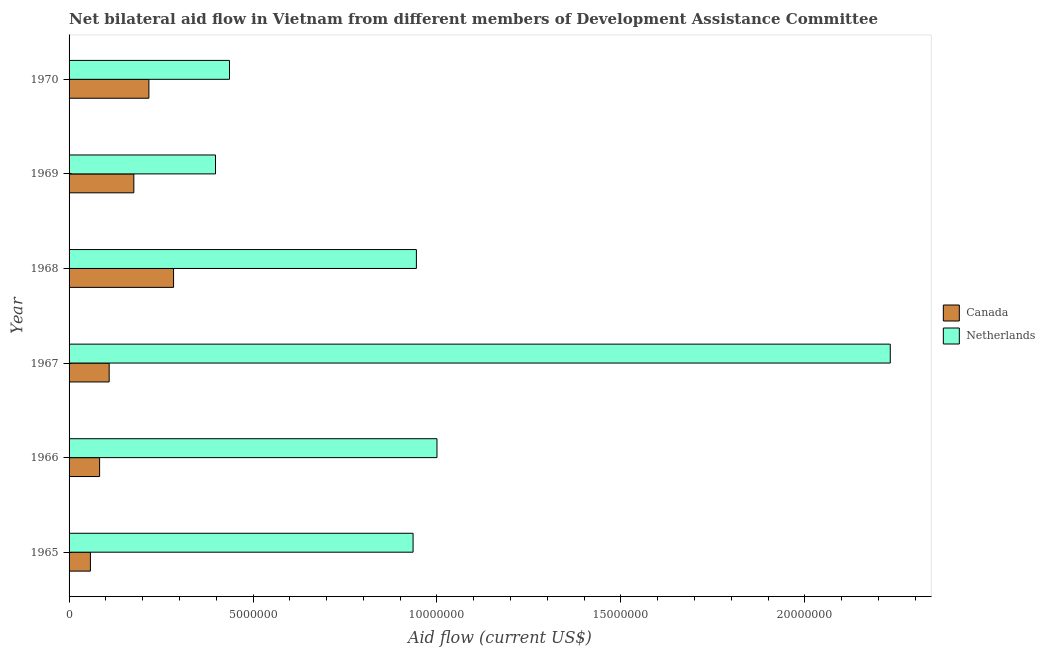Are the number of bars per tick equal to the number of legend labels?
Make the answer very short. Yes. Are the number of bars on each tick of the Y-axis equal?
Offer a terse response. Yes. What is the label of the 3rd group of bars from the top?
Provide a succinct answer. 1968. What is the amount of aid given by netherlands in 1965?
Your answer should be compact. 9.35e+06. Across all years, what is the maximum amount of aid given by canada?
Keep it short and to the point. 2.84e+06. Across all years, what is the minimum amount of aid given by netherlands?
Your answer should be very brief. 3.98e+06. In which year was the amount of aid given by netherlands maximum?
Provide a succinct answer. 1967. In which year was the amount of aid given by canada minimum?
Your answer should be compact. 1965. What is the total amount of aid given by netherlands in the graph?
Provide a succinct answer. 5.94e+07. What is the difference between the amount of aid given by netherlands in 1965 and that in 1967?
Provide a short and direct response. -1.30e+07. What is the difference between the amount of aid given by canada in 1966 and the amount of aid given by netherlands in 1970?
Make the answer very short. -3.53e+06. What is the average amount of aid given by canada per year?
Give a very brief answer. 1.54e+06. In the year 1969, what is the difference between the amount of aid given by canada and amount of aid given by netherlands?
Offer a very short reply. -2.22e+06. What is the ratio of the amount of aid given by canada in 1965 to that in 1969?
Your answer should be very brief. 0.33. Is the difference between the amount of aid given by netherlands in 1968 and 1969 greater than the difference between the amount of aid given by canada in 1968 and 1969?
Make the answer very short. Yes. What is the difference between the highest and the second highest amount of aid given by canada?
Your answer should be compact. 6.70e+05. What is the difference between the highest and the lowest amount of aid given by netherlands?
Offer a terse response. 1.83e+07. In how many years, is the amount of aid given by netherlands greater than the average amount of aid given by netherlands taken over all years?
Give a very brief answer. 2. What does the 2nd bar from the top in 1965 represents?
Keep it short and to the point. Canada. How many bars are there?
Your response must be concise. 12. How many years are there in the graph?
Keep it short and to the point. 6. Are the values on the major ticks of X-axis written in scientific E-notation?
Ensure brevity in your answer.  No. Does the graph contain any zero values?
Your answer should be compact. No. Does the graph contain grids?
Give a very brief answer. No. Where does the legend appear in the graph?
Your answer should be compact. Center right. How many legend labels are there?
Your answer should be compact. 2. What is the title of the graph?
Make the answer very short. Net bilateral aid flow in Vietnam from different members of Development Assistance Committee. Does "Lowest 20% of population" appear as one of the legend labels in the graph?
Offer a terse response. No. What is the Aid flow (current US$) of Canada in 1965?
Your answer should be compact. 5.80e+05. What is the Aid flow (current US$) of Netherlands in 1965?
Provide a short and direct response. 9.35e+06. What is the Aid flow (current US$) in Canada in 1966?
Your answer should be very brief. 8.30e+05. What is the Aid flow (current US$) of Netherlands in 1966?
Offer a very short reply. 1.00e+07. What is the Aid flow (current US$) of Canada in 1967?
Provide a short and direct response. 1.09e+06. What is the Aid flow (current US$) of Netherlands in 1967?
Make the answer very short. 2.23e+07. What is the Aid flow (current US$) of Canada in 1968?
Make the answer very short. 2.84e+06. What is the Aid flow (current US$) in Netherlands in 1968?
Ensure brevity in your answer.  9.44e+06. What is the Aid flow (current US$) in Canada in 1969?
Give a very brief answer. 1.76e+06. What is the Aid flow (current US$) of Netherlands in 1969?
Provide a succinct answer. 3.98e+06. What is the Aid flow (current US$) of Canada in 1970?
Make the answer very short. 2.17e+06. What is the Aid flow (current US$) in Netherlands in 1970?
Keep it short and to the point. 4.36e+06. Across all years, what is the maximum Aid flow (current US$) in Canada?
Provide a short and direct response. 2.84e+06. Across all years, what is the maximum Aid flow (current US$) of Netherlands?
Ensure brevity in your answer.  2.23e+07. Across all years, what is the minimum Aid flow (current US$) of Canada?
Your answer should be very brief. 5.80e+05. Across all years, what is the minimum Aid flow (current US$) in Netherlands?
Provide a succinct answer. 3.98e+06. What is the total Aid flow (current US$) of Canada in the graph?
Your answer should be very brief. 9.27e+06. What is the total Aid flow (current US$) in Netherlands in the graph?
Give a very brief answer. 5.94e+07. What is the difference between the Aid flow (current US$) of Canada in 1965 and that in 1966?
Ensure brevity in your answer.  -2.50e+05. What is the difference between the Aid flow (current US$) in Netherlands in 1965 and that in 1966?
Offer a terse response. -6.50e+05. What is the difference between the Aid flow (current US$) of Canada in 1965 and that in 1967?
Offer a terse response. -5.10e+05. What is the difference between the Aid flow (current US$) of Netherlands in 1965 and that in 1967?
Ensure brevity in your answer.  -1.30e+07. What is the difference between the Aid flow (current US$) of Canada in 1965 and that in 1968?
Ensure brevity in your answer.  -2.26e+06. What is the difference between the Aid flow (current US$) in Netherlands in 1965 and that in 1968?
Give a very brief answer. -9.00e+04. What is the difference between the Aid flow (current US$) of Canada in 1965 and that in 1969?
Your answer should be compact. -1.18e+06. What is the difference between the Aid flow (current US$) in Netherlands in 1965 and that in 1969?
Make the answer very short. 5.37e+06. What is the difference between the Aid flow (current US$) in Canada in 1965 and that in 1970?
Offer a very short reply. -1.59e+06. What is the difference between the Aid flow (current US$) in Netherlands in 1965 and that in 1970?
Offer a terse response. 4.99e+06. What is the difference between the Aid flow (current US$) of Canada in 1966 and that in 1967?
Give a very brief answer. -2.60e+05. What is the difference between the Aid flow (current US$) of Netherlands in 1966 and that in 1967?
Provide a succinct answer. -1.23e+07. What is the difference between the Aid flow (current US$) in Canada in 1966 and that in 1968?
Provide a short and direct response. -2.01e+06. What is the difference between the Aid flow (current US$) of Netherlands in 1966 and that in 1968?
Give a very brief answer. 5.60e+05. What is the difference between the Aid flow (current US$) in Canada in 1966 and that in 1969?
Offer a very short reply. -9.30e+05. What is the difference between the Aid flow (current US$) of Netherlands in 1966 and that in 1969?
Your answer should be compact. 6.02e+06. What is the difference between the Aid flow (current US$) in Canada in 1966 and that in 1970?
Offer a terse response. -1.34e+06. What is the difference between the Aid flow (current US$) in Netherlands in 1966 and that in 1970?
Ensure brevity in your answer.  5.64e+06. What is the difference between the Aid flow (current US$) in Canada in 1967 and that in 1968?
Give a very brief answer. -1.75e+06. What is the difference between the Aid flow (current US$) of Netherlands in 1967 and that in 1968?
Offer a very short reply. 1.29e+07. What is the difference between the Aid flow (current US$) of Canada in 1967 and that in 1969?
Ensure brevity in your answer.  -6.70e+05. What is the difference between the Aid flow (current US$) of Netherlands in 1967 and that in 1969?
Offer a very short reply. 1.83e+07. What is the difference between the Aid flow (current US$) in Canada in 1967 and that in 1970?
Keep it short and to the point. -1.08e+06. What is the difference between the Aid flow (current US$) of Netherlands in 1967 and that in 1970?
Ensure brevity in your answer.  1.80e+07. What is the difference between the Aid flow (current US$) in Canada in 1968 and that in 1969?
Your answer should be compact. 1.08e+06. What is the difference between the Aid flow (current US$) in Netherlands in 1968 and that in 1969?
Your answer should be compact. 5.46e+06. What is the difference between the Aid flow (current US$) in Canada in 1968 and that in 1970?
Provide a succinct answer. 6.70e+05. What is the difference between the Aid flow (current US$) in Netherlands in 1968 and that in 1970?
Provide a short and direct response. 5.08e+06. What is the difference between the Aid flow (current US$) in Canada in 1969 and that in 1970?
Keep it short and to the point. -4.10e+05. What is the difference between the Aid flow (current US$) in Netherlands in 1969 and that in 1970?
Your answer should be very brief. -3.80e+05. What is the difference between the Aid flow (current US$) in Canada in 1965 and the Aid flow (current US$) in Netherlands in 1966?
Offer a very short reply. -9.42e+06. What is the difference between the Aid flow (current US$) in Canada in 1965 and the Aid flow (current US$) in Netherlands in 1967?
Ensure brevity in your answer.  -2.17e+07. What is the difference between the Aid flow (current US$) in Canada in 1965 and the Aid flow (current US$) in Netherlands in 1968?
Ensure brevity in your answer.  -8.86e+06. What is the difference between the Aid flow (current US$) in Canada in 1965 and the Aid flow (current US$) in Netherlands in 1969?
Make the answer very short. -3.40e+06. What is the difference between the Aid flow (current US$) in Canada in 1965 and the Aid flow (current US$) in Netherlands in 1970?
Offer a terse response. -3.78e+06. What is the difference between the Aid flow (current US$) of Canada in 1966 and the Aid flow (current US$) of Netherlands in 1967?
Offer a terse response. -2.15e+07. What is the difference between the Aid flow (current US$) of Canada in 1966 and the Aid flow (current US$) of Netherlands in 1968?
Provide a succinct answer. -8.61e+06. What is the difference between the Aid flow (current US$) in Canada in 1966 and the Aid flow (current US$) in Netherlands in 1969?
Keep it short and to the point. -3.15e+06. What is the difference between the Aid flow (current US$) of Canada in 1966 and the Aid flow (current US$) of Netherlands in 1970?
Your response must be concise. -3.53e+06. What is the difference between the Aid flow (current US$) in Canada in 1967 and the Aid flow (current US$) in Netherlands in 1968?
Your response must be concise. -8.35e+06. What is the difference between the Aid flow (current US$) of Canada in 1967 and the Aid flow (current US$) of Netherlands in 1969?
Provide a short and direct response. -2.89e+06. What is the difference between the Aid flow (current US$) in Canada in 1967 and the Aid flow (current US$) in Netherlands in 1970?
Your answer should be very brief. -3.27e+06. What is the difference between the Aid flow (current US$) of Canada in 1968 and the Aid flow (current US$) of Netherlands in 1969?
Provide a succinct answer. -1.14e+06. What is the difference between the Aid flow (current US$) of Canada in 1968 and the Aid flow (current US$) of Netherlands in 1970?
Your answer should be compact. -1.52e+06. What is the difference between the Aid flow (current US$) in Canada in 1969 and the Aid flow (current US$) in Netherlands in 1970?
Make the answer very short. -2.60e+06. What is the average Aid flow (current US$) in Canada per year?
Your response must be concise. 1.54e+06. What is the average Aid flow (current US$) in Netherlands per year?
Keep it short and to the point. 9.91e+06. In the year 1965, what is the difference between the Aid flow (current US$) of Canada and Aid flow (current US$) of Netherlands?
Keep it short and to the point. -8.77e+06. In the year 1966, what is the difference between the Aid flow (current US$) in Canada and Aid flow (current US$) in Netherlands?
Give a very brief answer. -9.17e+06. In the year 1967, what is the difference between the Aid flow (current US$) of Canada and Aid flow (current US$) of Netherlands?
Your answer should be compact. -2.12e+07. In the year 1968, what is the difference between the Aid flow (current US$) of Canada and Aid flow (current US$) of Netherlands?
Your answer should be compact. -6.60e+06. In the year 1969, what is the difference between the Aid flow (current US$) in Canada and Aid flow (current US$) in Netherlands?
Your answer should be compact. -2.22e+06. In the year 1970, what is the difference between the Aid flow (current US$) of Canada and Aid flow (current US$) of Netherlands?
Provide a short and direct response. -2.19e+06. What is the ratio of the Aid flow (current US$) of Canada in 1965 to that in 1966?
Your answer should be very brief. 0.7. What is the ratio of the Aid flow (current US$) in Netherlands in 1965 to that in 1966?
Your response must be concise. 0.94. What is the ratio of the Aid flow (current US$) of Canada in 1965 to that in 1967?
Give a very brief answer. 0.53. What is the ratio of the Aid flow (current US$) in Netherlands in 1965 to that in 1967?
Your answer should be very brief. 0.42. What is the ratio of the Aid flow (current US$) in Canada in 1965 to that in 1968?
Ensure brevity in your answer.  0.2. What is the ratio of the Aid flow (current US$) of Canada in 1965 to that in 1969?
Provide a short and direct response. 0.33. What is the ratio of the Aid flow (current US$) in Netherlands in 1965 to that in 1969?
Offer a very short reply. 2.35. What is the ratio of the Aid flow (current US$) in Canada in 1965 to that in 1970?
Your answer should be very brief. 0.27. What is the ratio of the Aid flow (current US$) of Netherlands in 1965 to that in 1970?
Provide a succinct answer. 2.14. What is the ratio of the Aid flow (current US$) of Canada in 1966 to that in 1967?
Keep it short and to the point. 0.76. What is the ratio of the Aid flow (current US$) in Netherlands in 1966 to that in 1967?
Your answer should be compact. 0.45. What is the ratio of the Aid flow (current US$) in Canada in 1966 to that in 1968?
Offer a very short reply. 0.29. What is the ratio of the Aid flow (current US$) of Netherlands in 1966 to that in 1968?
Your response must be concise. 1.06. What is the ratio of the Aid flow (current US$) in Canada in 1966 to that in 1969?
Offer a very short reply. 0.47. What is the ratio of the Aid flow (current US$) in Netherlands in 1966 to that in 1969?
Offer a very short reply. 2.51. What is the ratio of the Aid flow (current US$) of Canada in 1966 to that in 1970?
Offer a terse response. 0.38. What is the ratio of the Aid flow (current US$) of Netherlands in 1966 to that in 1970?
Give a very brief answer. 2.29. What is the ratio of the Aid flow (current US$) of Canada in 1967 to that in 1968?
Give a very brief answer. 0.38. What is the ratio of the Aid flow (current US$) in Netherlands in 1967 to that in 1968?
Keep it short and to the point. 2.36. What is the ratio of the Aid flow (current US$) in Canada in 1967 to that in 1969?
Give a very brief answer. 0.62. What is the ratio of the Aid flow (current US$) of Netherlands in 1967 to that in 1969?
Keep it short and to the point. 5.61. What is the ratio of the Aid flow (current US$) in Canada in 1967 to that in 1970?
Your answer should be compact. 0.5. What is the ratio of the Aid flow (current US$) in Netherlands in 1967 to that in 1970?
Your answer should be very brief. 5.12. What is the ratio of the Aid flow (current US$) of Canada in 1968 to that in 1969?
Offer a very short reply. 1.61. What is the ratio of the Aid flow (current US$) of Netherlands in 1968 to that in 1969?
Ensure brevity in your answer.  2.37. What is the ratio of the Aid flow (current US$) in Canada in 1968 to that in 1970?
Offer a very short reply. 1.31. What is the ratio of the Aid flow (current US$) in Netherlands in 1968 to that in 1970?
Provide a succinct answer. 2.17. What is the ratio of the Aid flow (current US$) of Canada in 1969 to that in 1970?
Offer a very short reply. 0.81. What is the ratio of the Aid flow (current US$) in Netherlands in 1969 to that in 1970?
Your answer should be very brief. 0.91. What is the difference between the highest and the second highest Aid flow (current US$) in Canada?
Your answer should be compact. 6.70e+05. What is the difference between the highest and the second highest Aid flow (current US$) of Netherlands?
Provide a short and direct response. 1.23e+07. What is the difference between the highest and the lowest Aid flow (current US$) in Canada?
Make the answer very short. 2.26e+06. What is the difference between the highest and the lowest Aid flow (current US$) in Netherlands?
Your response must be concise. 1.83e+07. 